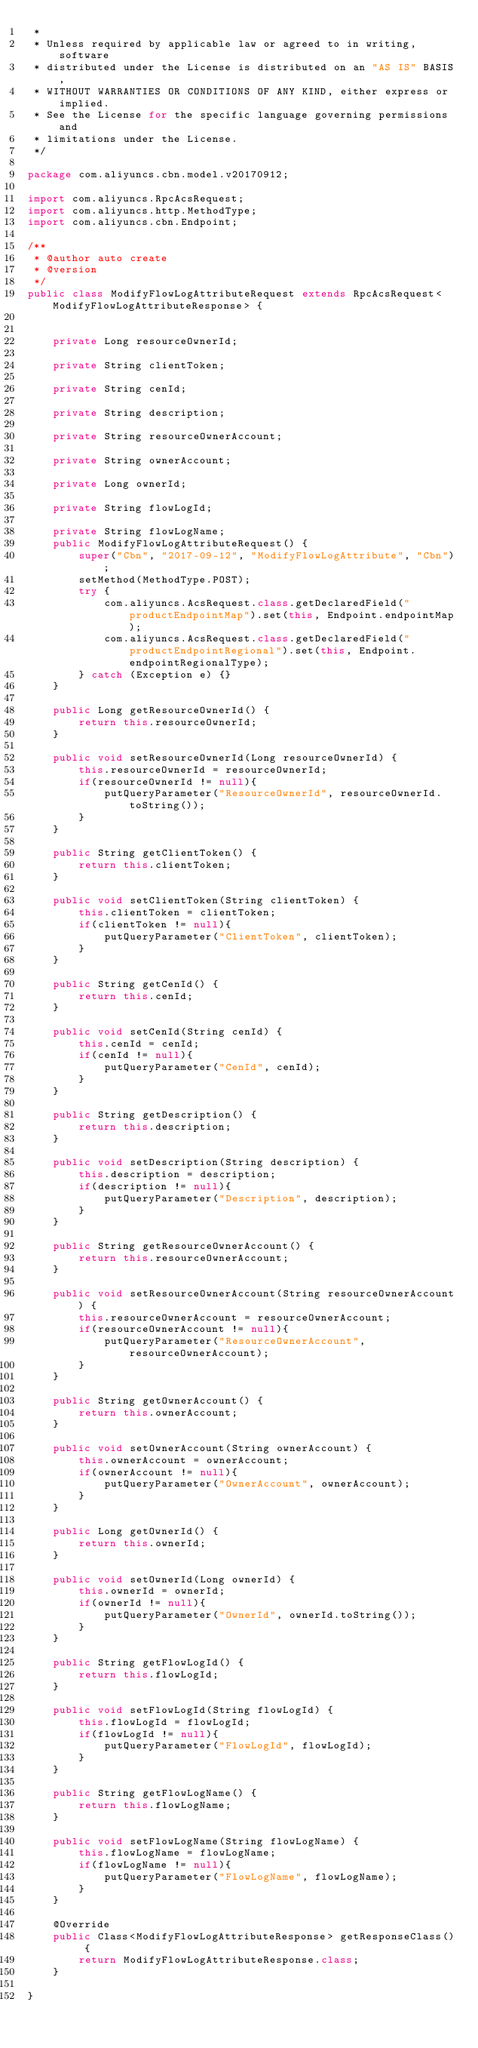Convert code to text. <code><loc_0><loc_0><loc_500><loc_500><_Java_> *
 * Unless required by applicable law or agreed to in writing, software
 * distributed under the License is distributed on an "AS IS" BASIS,
 * WITHOUT WARRANTIES OR CONDITIONS OF ANY KIND, either express or implied.
 * See the License for the specific language governing permissions and
 * limitations under the License.
 */

package com.aliyuncs.cbn.model.v20170912;

import com.aliyuncs.RpcAcsRequest;
import com.aliyuncs.http.MethodType;
import com.aliyuncs.cbn.Endpoint;

/**
 * @author auto create
 * @version 
 */
public class ModifyFlowLogAttributeRequest extends RpcAcsRequest<ModifyFlowLogAttributeResponse> {
	   

	private Long resourceOwnerId;

	private String clientToken;

	private String cenId;

	private String description;

	private String resourceOwnerAccount;

	private String ownerAccount;

	private Long ownerId;

	private String flowLogId;

	private String flowLogName;
	public ModifyFlowLogAttributeRequest() {
		super("Cbn", "2017-09-12", "ModifyFlowLogAttribute", "Cbn");
		setMethod(MethodType.POST);
		try {
			com.aliyuncs.AcsRequest.class.getDeclaredField("productEndpointMap").set(this, Endpoint.endpointMap);
			com.aliyuncs.AcsRequest.class.getDeclaredField("productEndpointRegional").set(this, Endpoint.endpointRegionalType);
		} catch (Exception e) {}
	}

	public Long getResourceOwnerId() {
		return this.resourceOwnerId;
	}

	public void setResourceOwnerId(Long resourceOwnerId) {
		this.resourceOwnerId = resourceOwnerId;
		if(resourceOwnerId != null){
			putQueryParameter("ResourceOwnerId", resourceOwnerId.toString());
		}
	}

	public String getClientToken() {
		return this.clientToken;
	}

	public void setClientToken(String clientToken) {
		this.clientToken = clientToken;
		if(clientToken != null){
			putQueryParameter("ClientToken", clientToken);
		}
	}

	public String getCenId() {
		return this.cenId;
	}

	public void setCenId(String cenId) {
		this.cenId = cenId;
		if(cenId != null){
			putQueryParameter("CenId", cenId);
		}
	}

	public String getDescription() {
		return this.description;
	}

	public void setDescription(String description) {
		this.description = description;
		if(description != null){
			putQueryParameter("Description", description);
		}
	}

	public String getResourceOwnerAccount() {
		return this.resourceOwnerAccount;
	}

	public void setResourceOwnerAccount(String resourceOwnerAccount) {
		this.resourceOwnerAccount = resourceOwnerAccount;
		if(resourceOwnerAccount != null){
			putQueryParameter("ResourceOwnerAccount", resourceOwnerAccount);
		}
	}

	public String getOwnerAccount() {
		return this.ownerAccount;
	}

	public void setOwnerAccount(String ownerAccount) {
		this.ownerAccount = ownerAccount;
		if(ownerAccount != null){
			putQueryParameter("OwnerAccount", ownerAccount);
		}
	}

	public Long getOwnerId() {
		return this.ownerId;
	}

	public void setOwnerId(Long ownerId) {
		this.ownerId = ownerId;
		if(ownerId != null){
			putQueryParameter("OwnerId", ownerId.toString());
		}
	}

	public String getFlowLogId() {
		return this.flowLogId;
	}

	public void setFlowLogId(String flowLogId) {
		this.flowLogId = flowLogId;
		if(flowLogId != null){
			putQueryParameter("FlowLogId", flowLogId);
		}
	}

	public String getFlowLogName() {
		return this.flowLogName;
	}

	public void setFlowLogName(String flowLogName) {
		this.flowLogName = flowLogName;
		if(flowLogName != null){
			putQueryParameter("FlowLogName", flowLogName);
		}
	}

	@Override
	public Class<ModifyFlowLogAttributeResponse> getResponseClass() {
		return ModifyFlowLogAttributeResponse.class;
	}

}
</code> 